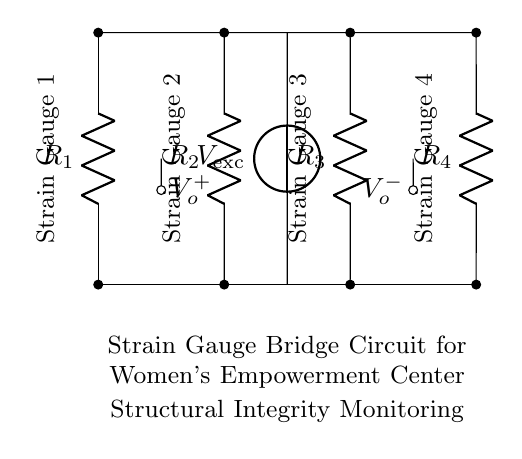What type of circuit is depicted in the diagram? The diagram shows a bridge circuit, particularly a strain gauge bridge, which is used to measure strain by detecting voltage changes.
Answer: bridge circuit What is the purpose of the strain gauge bridge in this context? The strain gauge bridge is used for structural integrity monitoring of women's empowerment centers, ensuring safety and reliability of the structures.
Answer: structural integrity monitoring How many strain gauges are included in the circuit? There are four strain gauges listed in the circuit, identified as Strain Gauge 1, Strain Gauge 2, Strain Gauge 3, and Strain Gauge 4.
Answer: four strain gauges What is the function of Vexc in the circuit? Vexc, or the excitation voltage, provides the necessary electrical energy to the strain gauges, allowing them to function and detect strain changes in the structure.
Answer: excitation voltage How are the strain gauges connected in the circuit? The strain gauges are connected in a balanced bridge configuration, where two gauges are in one arm and two in the opposite arm to measure differential changes effectively.
Answer: balanced bridge configuration What connections do the output nodes represent in this bridge circuit? The output nodes, V_o^+ and V_o^-, represent the voltage difference at the output of the strain gauge bridge, indicating the presence of any strain based on the bridge's balance.
Answer: voltage difference What is the significance of using a bridge circuit for this application? The bridge circuit is significant because it allows for precise measurements of small changes in resistance caused by strain, which is crucial for monitoring the integrity of structures like women's empowerment centers.
Answer: precise measurements 